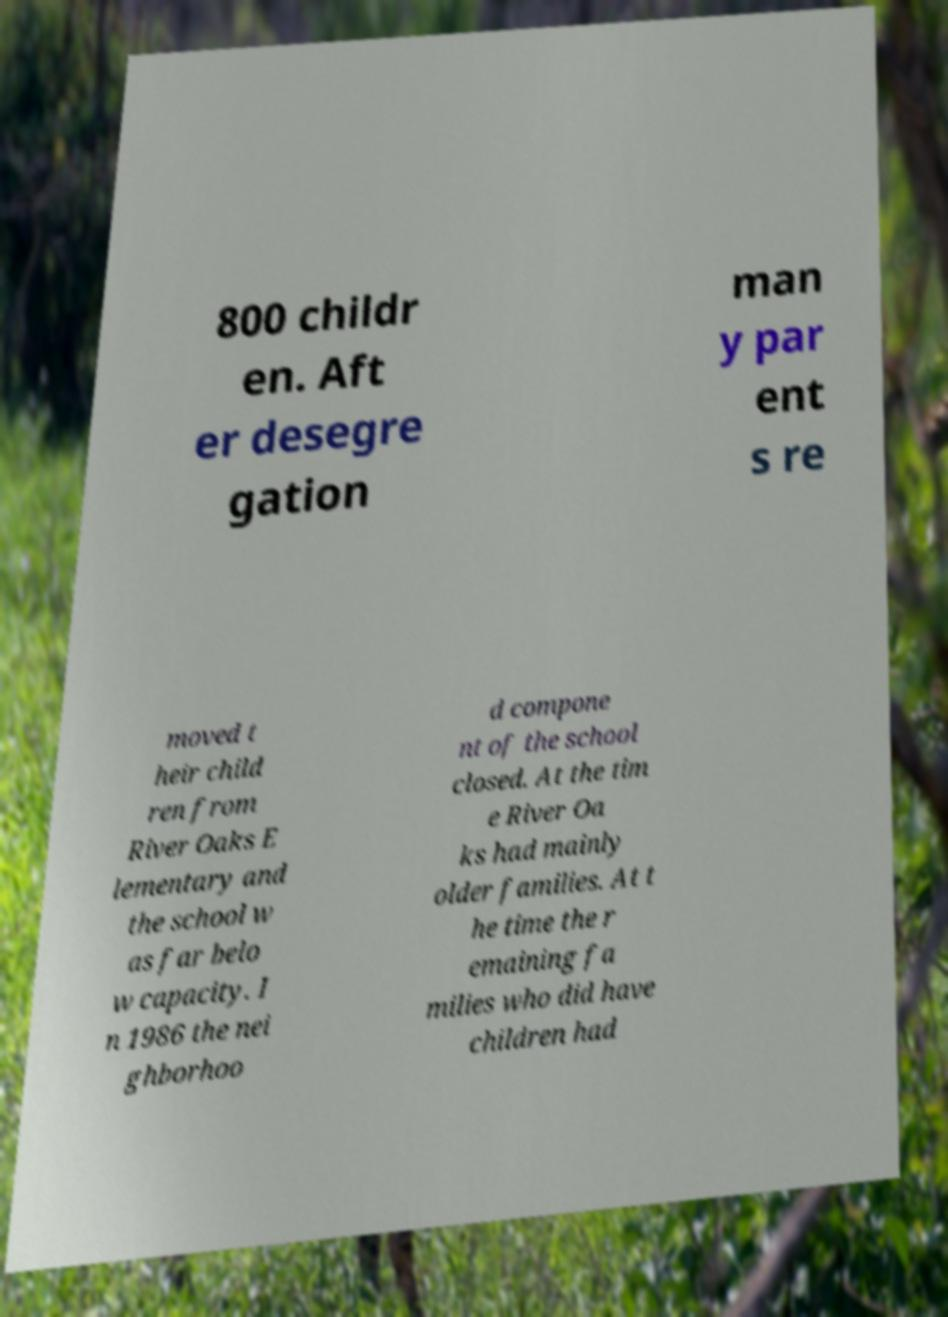There's text embedded in this image that I need extracted. Can you transcribe it verbatim? 800 childr en. Aft er desegre gation man y par ent s re moved t heir child ren from River Oaks E lementary and the school w as far belo w capacity. I n 1986 the nei ghborhoo d compone nt of the school closed. At the tim e River Oa ks had mainly older families. At t he time the r emaining fa milies who did have children had 